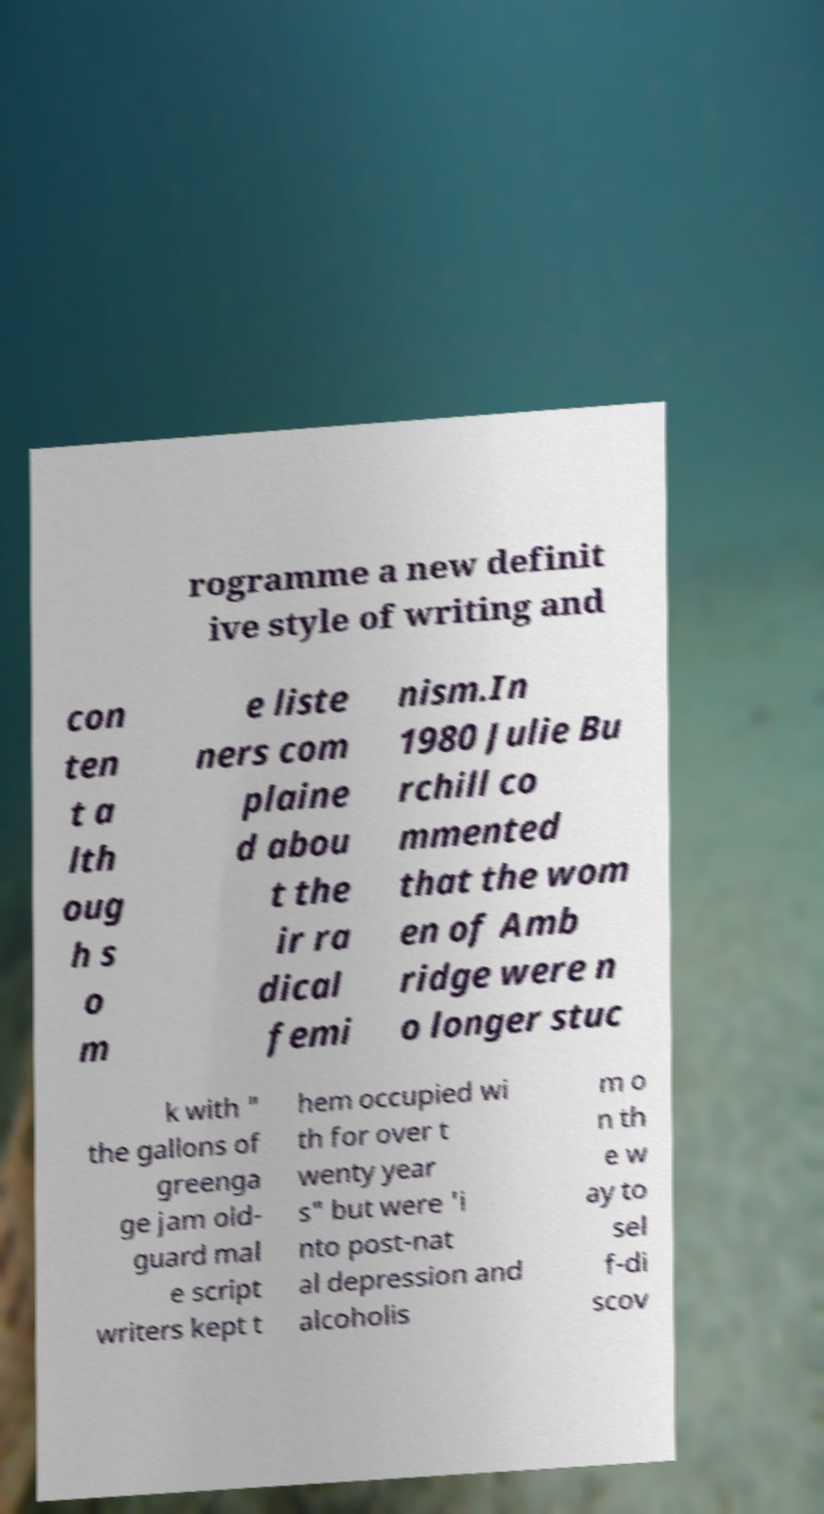Please read and relay the text visible in this image. What does it say? rogramme a new definit ive style of writing and con ten t a lth oug h s o m e liste ners com plaine d abou t the ir ra dical femi nism.In 1980 Julie Bu rchill co mmented that the wom en of Amb ridge were n o longer stuc k with " the gallons of greenga ge jam old- guard mal e script writers kept t hem occupied wi th for over t wenty year s" but were 'i nto post-nat al depression and alcoholis m o n th e w ay to sel f-di scov 